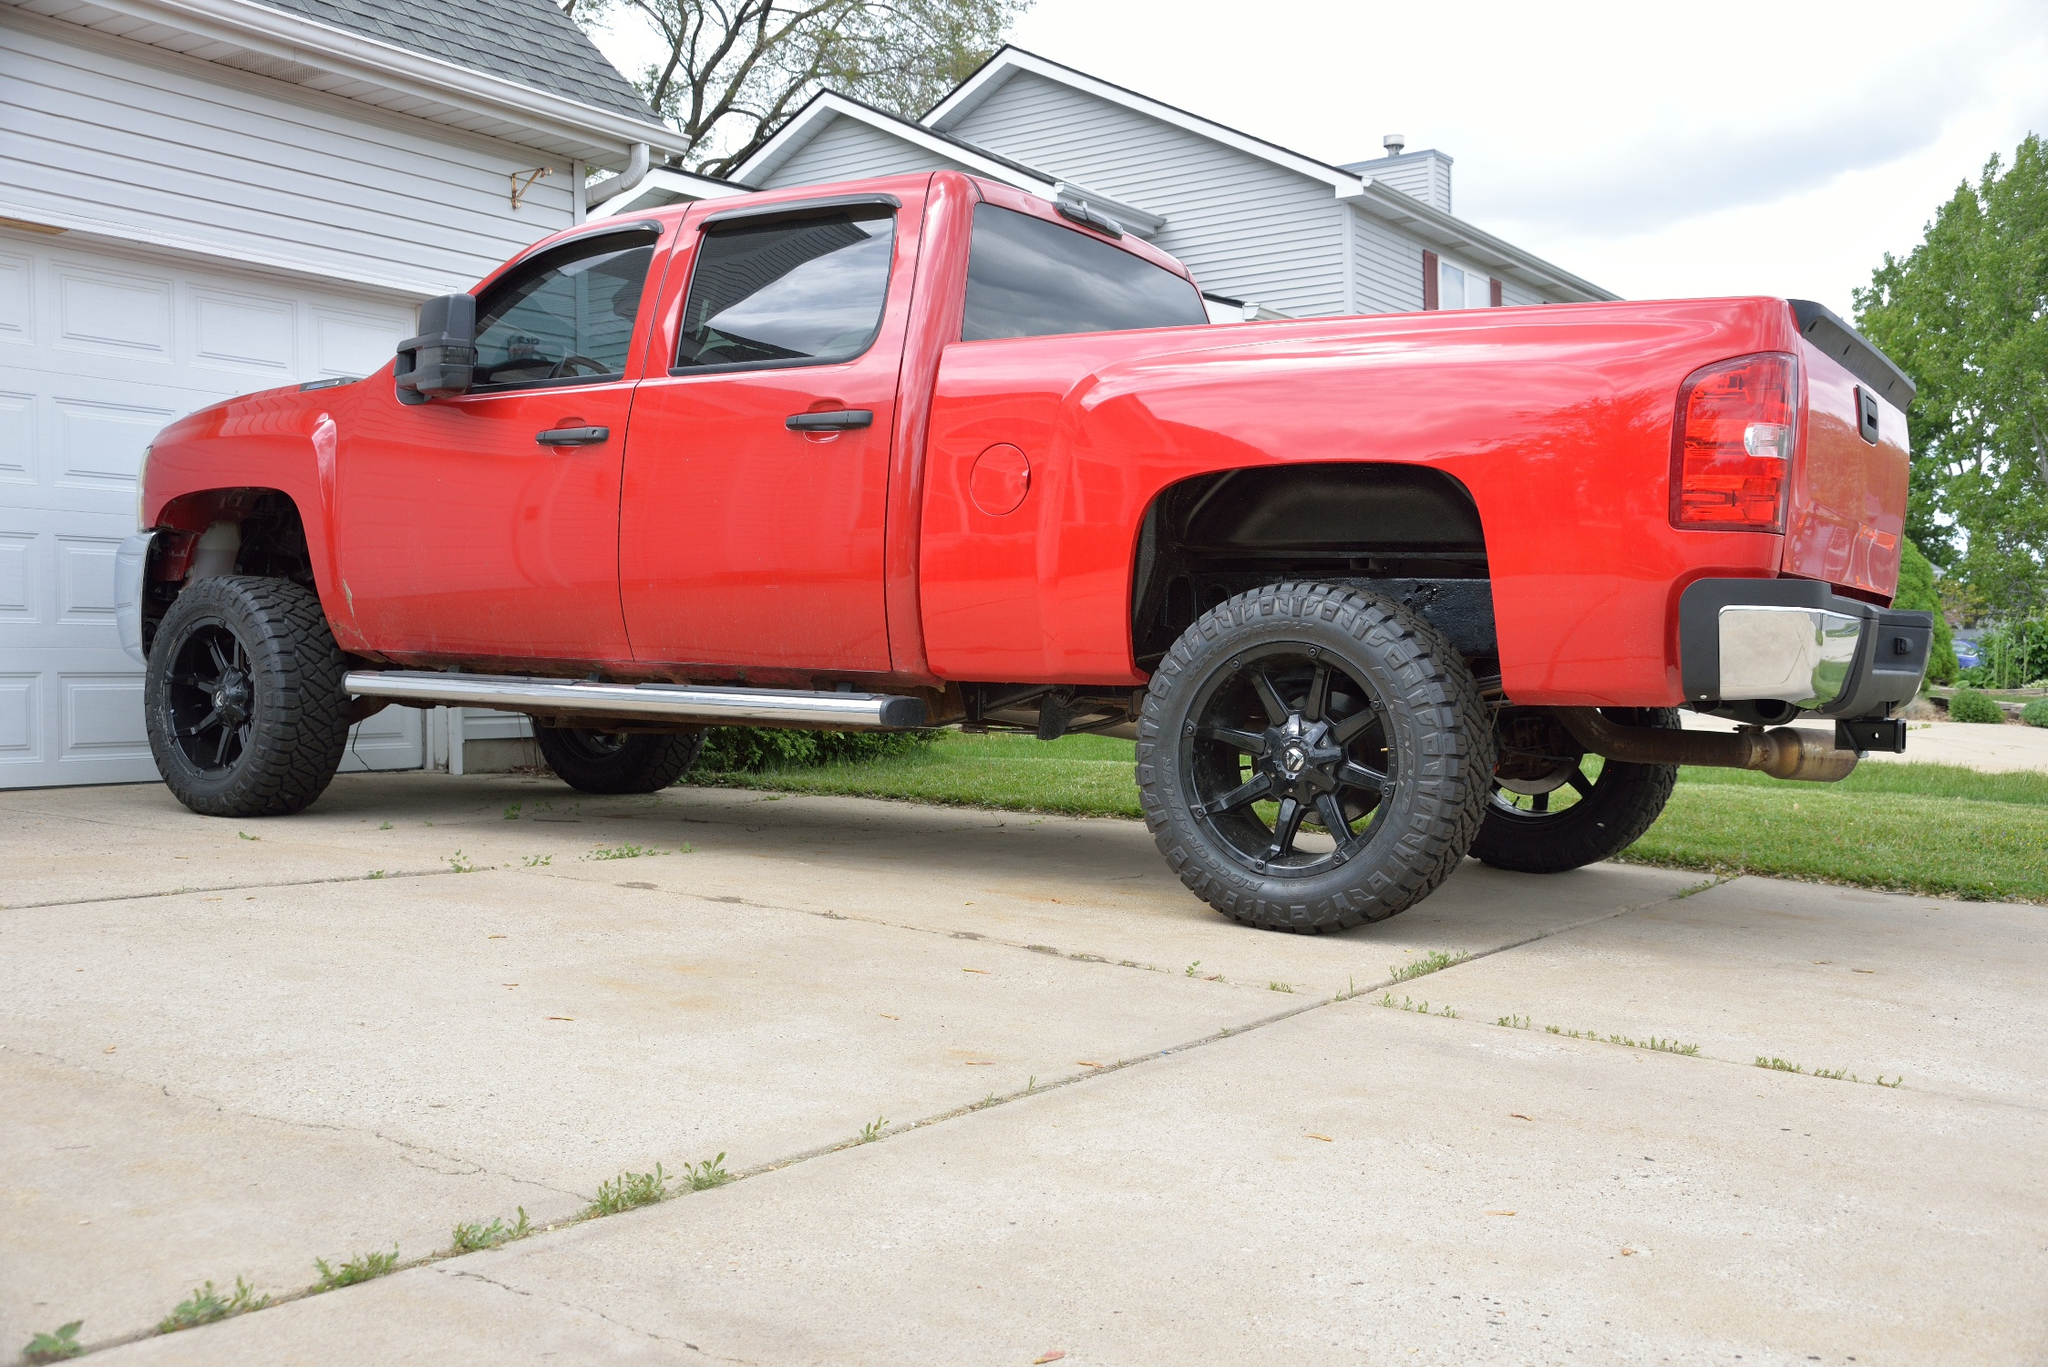What does this image suggest about the lifestyle or interests of the truck's owner? The prominent display of the large, lifted red pickup truck with sleek black rims suggests the owner might have a keen interest in automotive culture, specifically in powerful and visually imposing vehicles. This type of truck is often associated with outdoorsy lifestyles, possibly implying the owner enjoys activities like off-roading or camping. The meticulous condition of the truck and the tidy surrounding also hint at a preference for order and care in maintenance, suggesting a sense of pride in their possessions. 